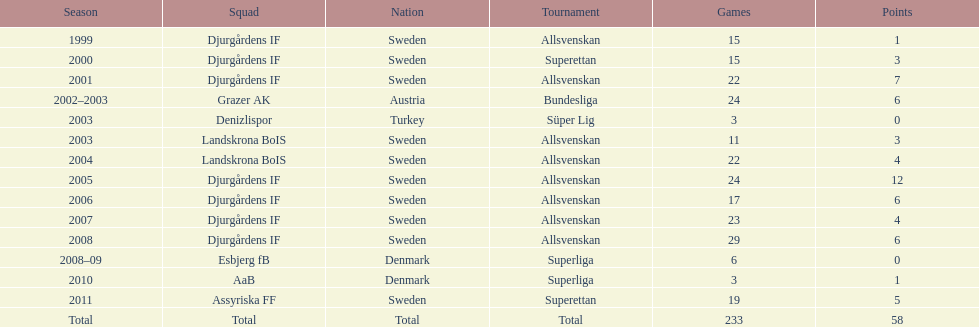How many total goals has jones kusi-asare scored? 58. 